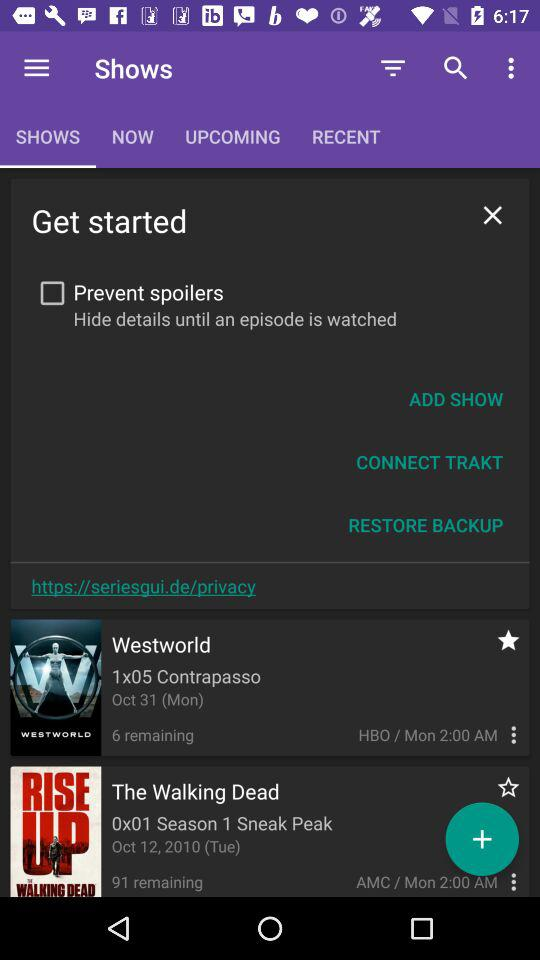Which tab has been selected? The tab that has been selected is "SHOWS". 